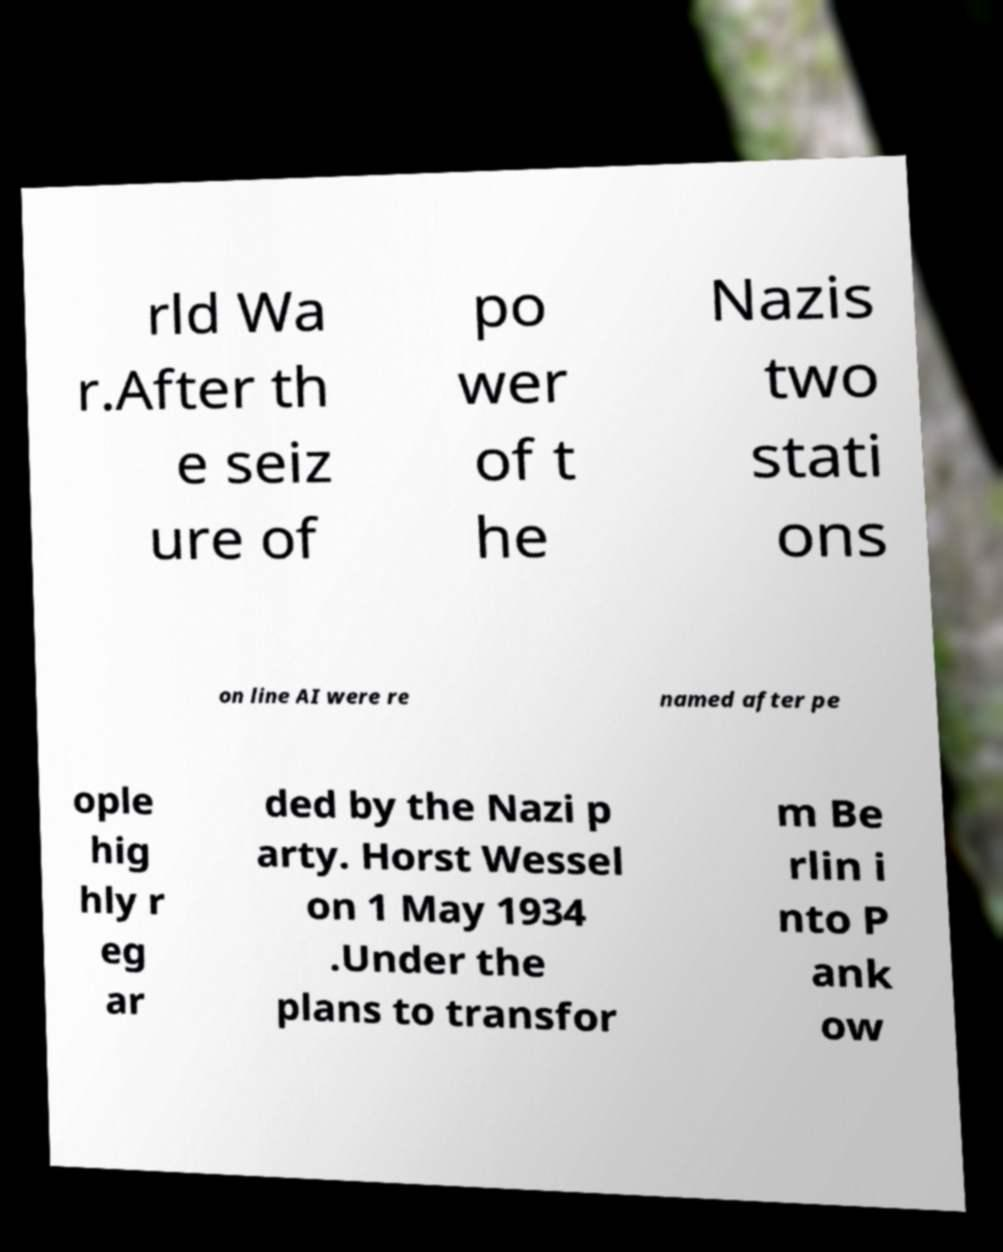For documentation purposes, I need the text within this image transcribed. Could you provide that? rld Wa r.After th e seiz ure of po wer of t he Nazis two stati ons on line AI were re named after pe ople hig hly r eg ar ded by the Nazi p arty. Horst Wessel on 1 May 1934 .Under the plans to transfor m Be rlin i nto P ank ow 